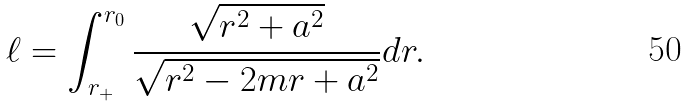<formula> <loc_0><loc_0><loc_500><loc_500>\ell = \int _ { r _ { + } } ^ { r _ { 0 } } \frac { \sqrt { r ^ { 2 } + a ^ { 2 } } } { \sqrt { r ^ { 2 } - 2 m r + a ^ { 2 } } } d r .</formula> 